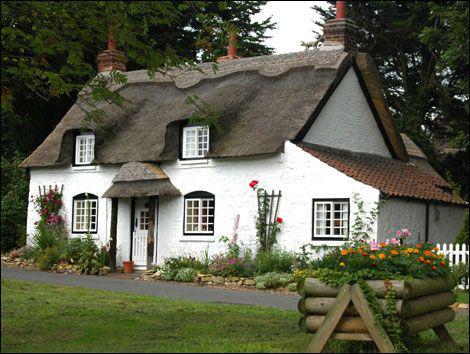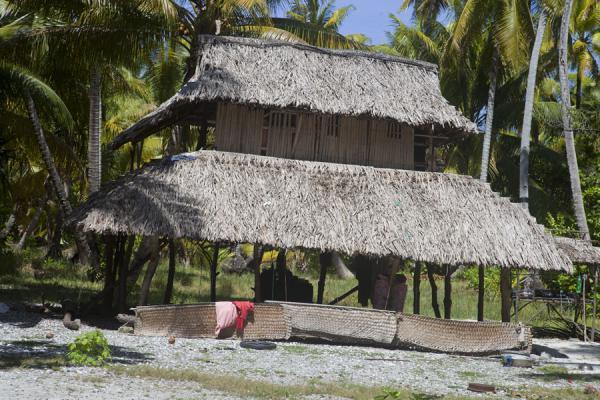The first image is the image on the left, the second image is the image on the right. Examine the images to the left and right. Is the description "The left image features a white house with at least two notches in its roof to accomodate windows and a sculpted border along the top of the roof." accurate? Answer yes or no. Yes. The first image is the image on the left, the second image is the image on the right. Evaluate the accuracy of this statement regarding the images: "On the left a green lawn rises up to meet a white country cottage.". Is it true? Answer yes or no. Yes. 